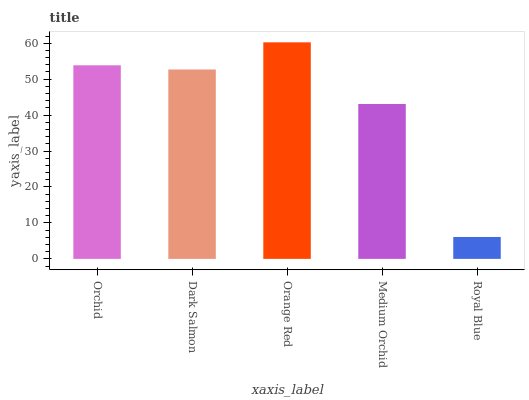Is Dark Salmon the minimum?
Answer yes or no. No. Is Dark Salmon the maximum?
Answer yes or no. No. Is Orchid greater than Dark Salmon?
Answer yes or no. Yes. Is Dark Salmon less than Orchid?
Answer yes or no. Yes. Is Dark Salmon greater than Orchid?
Answer yes or no. No. Is Orchid less than Dark Salmon?
Answer yes or no. No. Is Dark Salmon the high median?
Answer yes or no. Yes. Is Dark Salmon the low median?
Answer yes or no. Yes. Is Medium Orchid the high median?
Answer yes or no. No. Is Medium Orchid the low median?
Answer yes or no. No. 